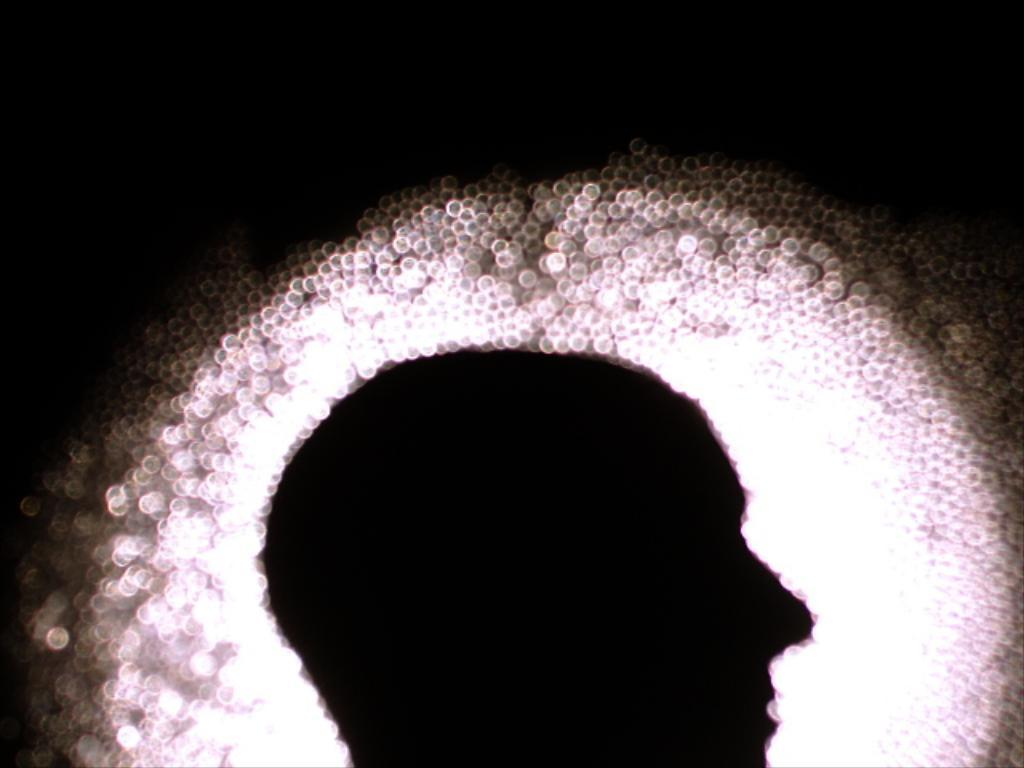What is the main subject of the image? There is a person's face in the image. What else can be seen in the image besides the person's face? There are lights visible in the image. How would you describe the background of the image? The background of the image is dark. What type of jelly is being used to illuminate the person's face in the image? There is no jelly present in the image, and it is not being used to illuminate the person's face. 